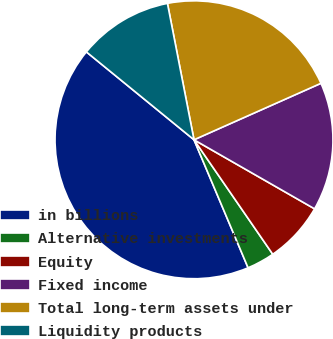Convert chart. <chart><loc_0><loc_0><loc_500><loc_500><pie_chart><fcel>in billions<fcel>Alternative investments<fcel>Equity<fcel>Fixed income<fcel>Total long-term assets under<fcel>Liquidity products<nl><fcel>42.26%<fcel>3.23%<fcel>7.13%<fcel>14.94%<fcel>21.4%<fcel>11.04%<nl></chart> 